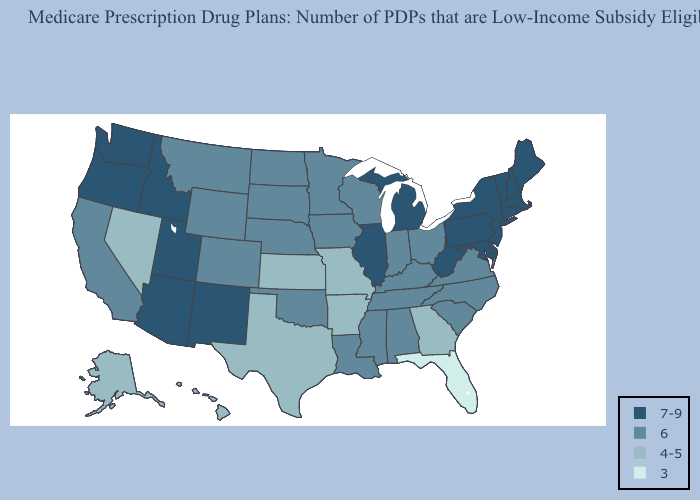Among the states that border Washington , which have the lowest value?
Keep it brief. Idaho, Oregon. Does Ohio have a lower value than Georgia?
Quick response, please. No. What is the lowest value in states that border Alabama?
Answer briefly. 3. Among the states that border Kansas , which have the lowest value?
Be succinct. Missouri. What is the lowest value in states that border Wyoming?
Keep it brief. 6. Name the states that have a value in the range 3?
Keep it brief. Florida. What is the value of Colorado?
Keep it brief. 6. Does South Carolina have a lower value than Arizona?
Give a very brief answer. Yes. What is the value of Kentucky?
Short answer required. 6. Does Illinois have a lower value than Maryland?
Quick response, please. No. Name the states that have a value in the range 4-5?
Quick response, please. Alaska, Arkansas, Georgia, Hawaii, Kansas, Missouri, Nevada, Texas. Does the map have missing data?
Answer briefly. No. Is the legend a continuous bar?
Concise answer only. No. What is the value of Rhode Island?
Short answer required. 7-9. 